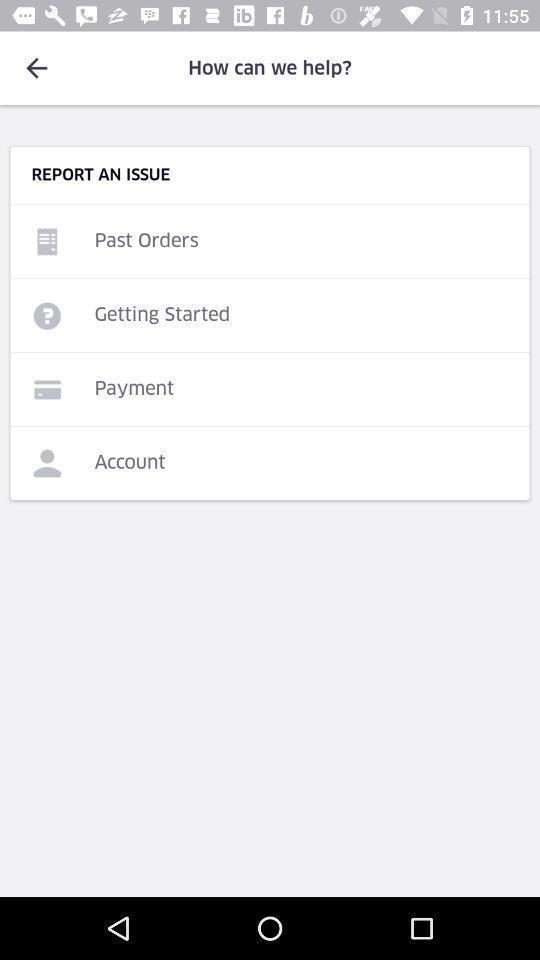Summarize the main components in this picture. Screen showing report an issue. 